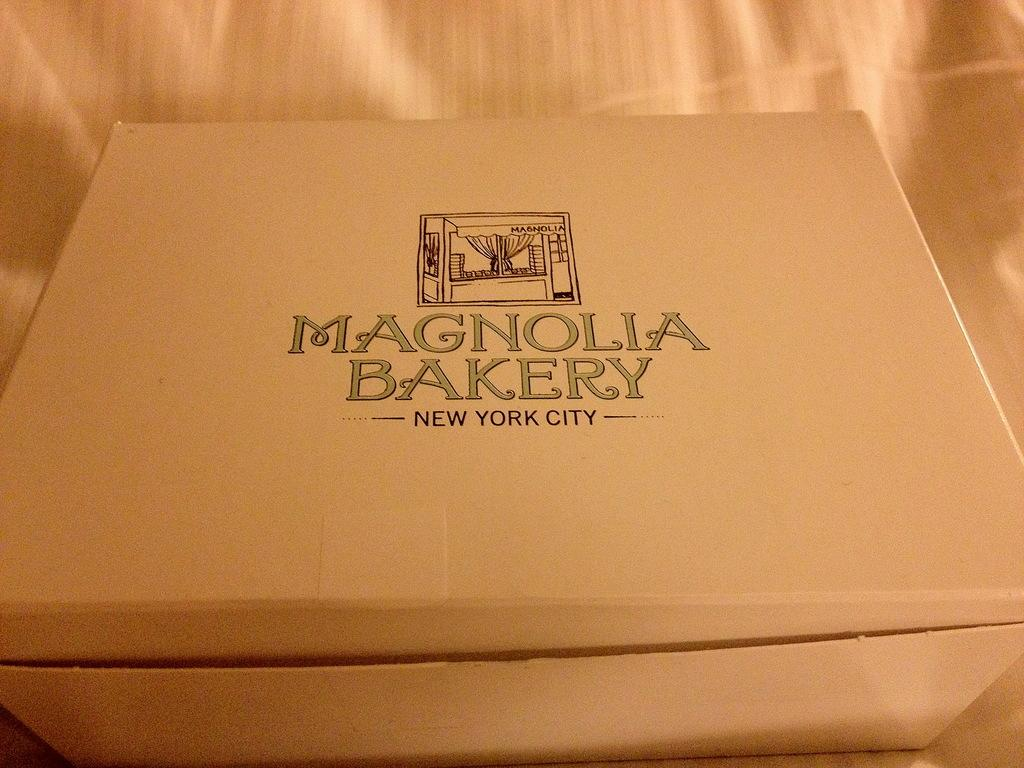What object is located towards the bottom of the image? There is a box in the image, and it is located towards the bottom. What can be found on the surface of the box? There is text on the box. What type of material can be seen in the background of the image? There is a cloth visible in the background of the image. Can you tell me how many toys are on the furniture in the image? There are no toys or furniture present in the image; it only features a box and a cloth in the background. 